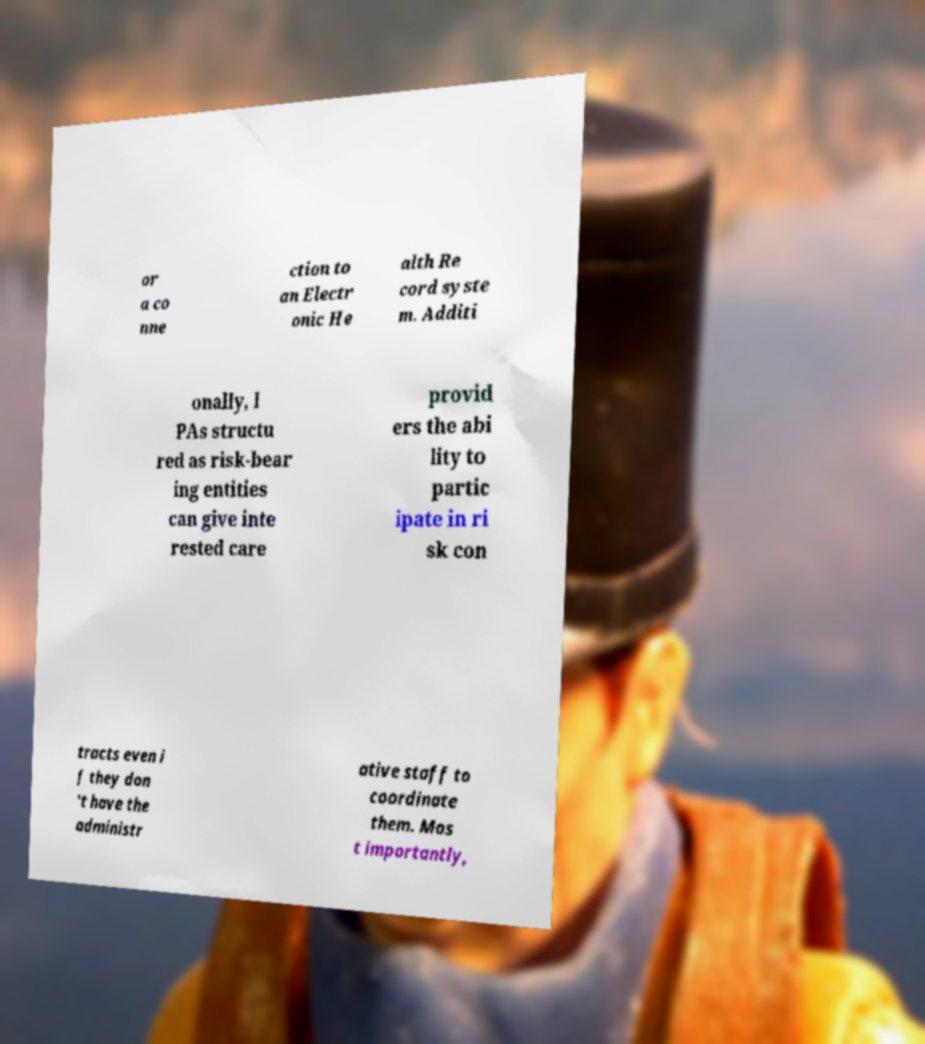For documentation purposes, I need the text within this image transcribed. Could you provide that? or a co nne ction to an Electr onic He alth Re cord syste m. Additi onally, I PAs structu red as risk-bear ing entities can give inte rested care provid ers the abi lity to partic ipate in ri sk con tracts even i f they don 't have the administr ative staff to coordinate them. Mos t importantly, 